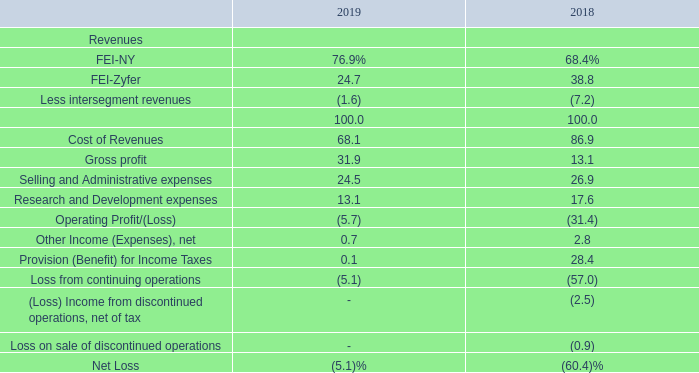Consolidated Results
The table below sets forth for the fiscal years ended April 30, 2019 and 2018, the percentage of consolidated net sales represented by certain items in the Company’s consolidated statements of operations:
What is the percentage of revenue from FEI-NY in 2018 and 2019 respectively? 68.4%, 76.9%. What is the percentage of revenue from FEI-Zyfer in 2018 and 2019 respectively? 38.8, 24.7. What does the table show? For the fiscal years ended april 30, 2019 and 2018, the percentage of consolidated net sales represented by certain items in the company’s consolidated statements of operations. What is the difference in percentage of revenues from FEI-NY between 2019 and 2018?
Answer scale should be: percent. 76.9-68.4
Answer: 8.5. What is the average percentage of revenues from FEI-Zyfer in 2018 and 2019?
Answer scale should be: percent. (24.7+38.8)/2
Answer: 31.75. What is the average selling and administrative expenses in 2018 and 2019?
Answer scale should be: percent. (24.5+26.9)/2
Answer: 25.7. 